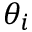Convert formula to latex. <formula><loc_0><loc_0><loc_500><loc_500>\theta _ { i }</formula> 